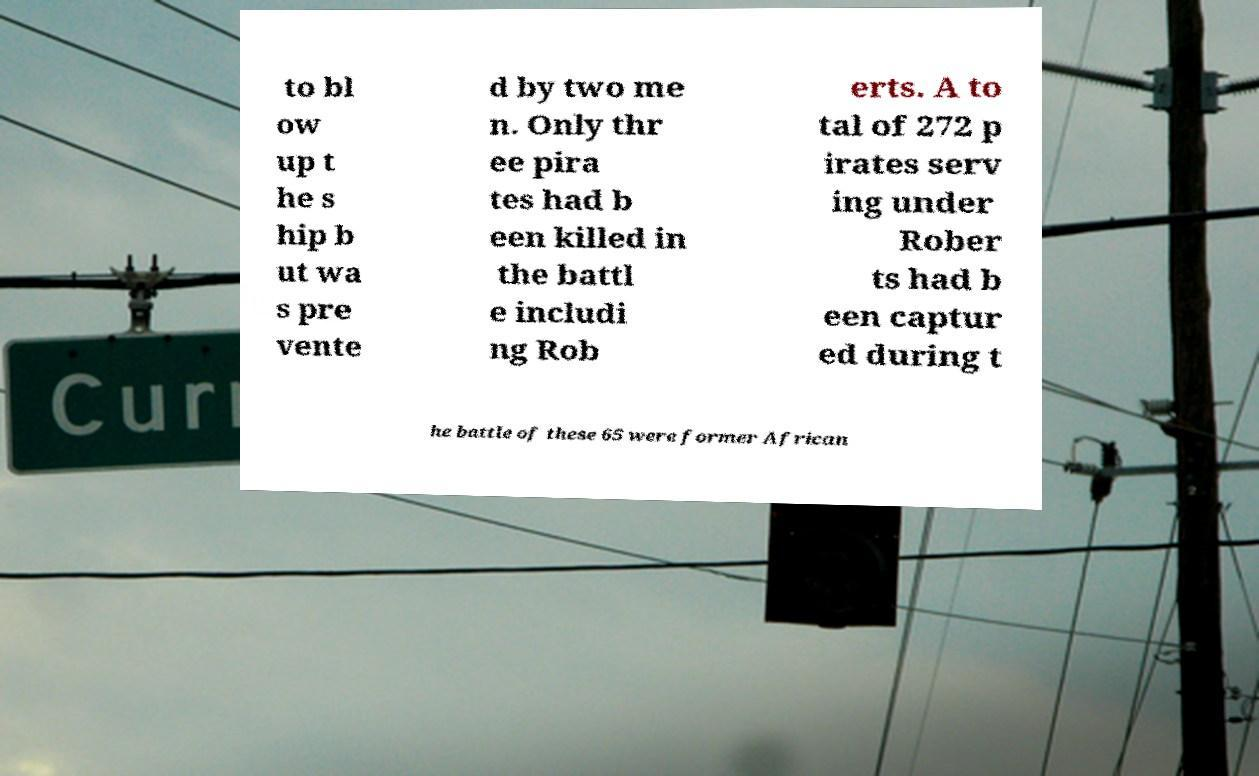Please read and relay the text visible in this image. What does it say? to bl ow up t he s hip b ut wa s pre vente d by two me n. Only thr ee pira tes had b een killed in the battl e includi ng Rob erts. A to tal of 272 p irates serv ing under Rober ts had b een captur ed during t he battle of these 65 were former African 